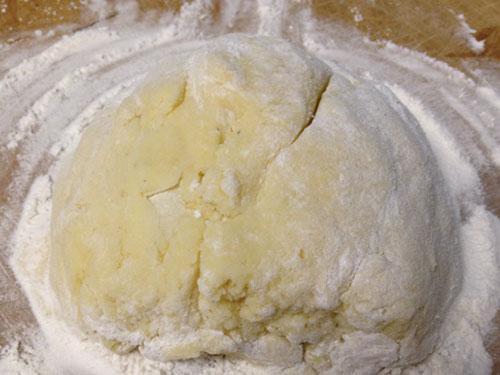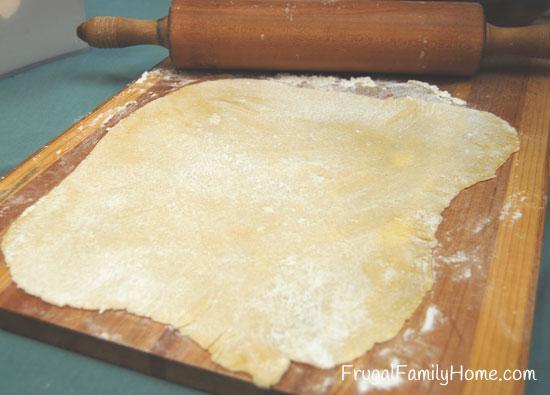The first image is the image on the left, the second image is the image on the right. For the images displayed, is the sentence "A rolling pin is on a wooden cutting board." factually correct? Answer yes or no. Yes. The first image is the image on the left, the second image is the image on the right. Examine the images to the left and right. Is the description "The left image shows dough in a roundish shape on a floured board, and the right image shows dough that has been flattened." accurate? Answer yes or no. Yes. 